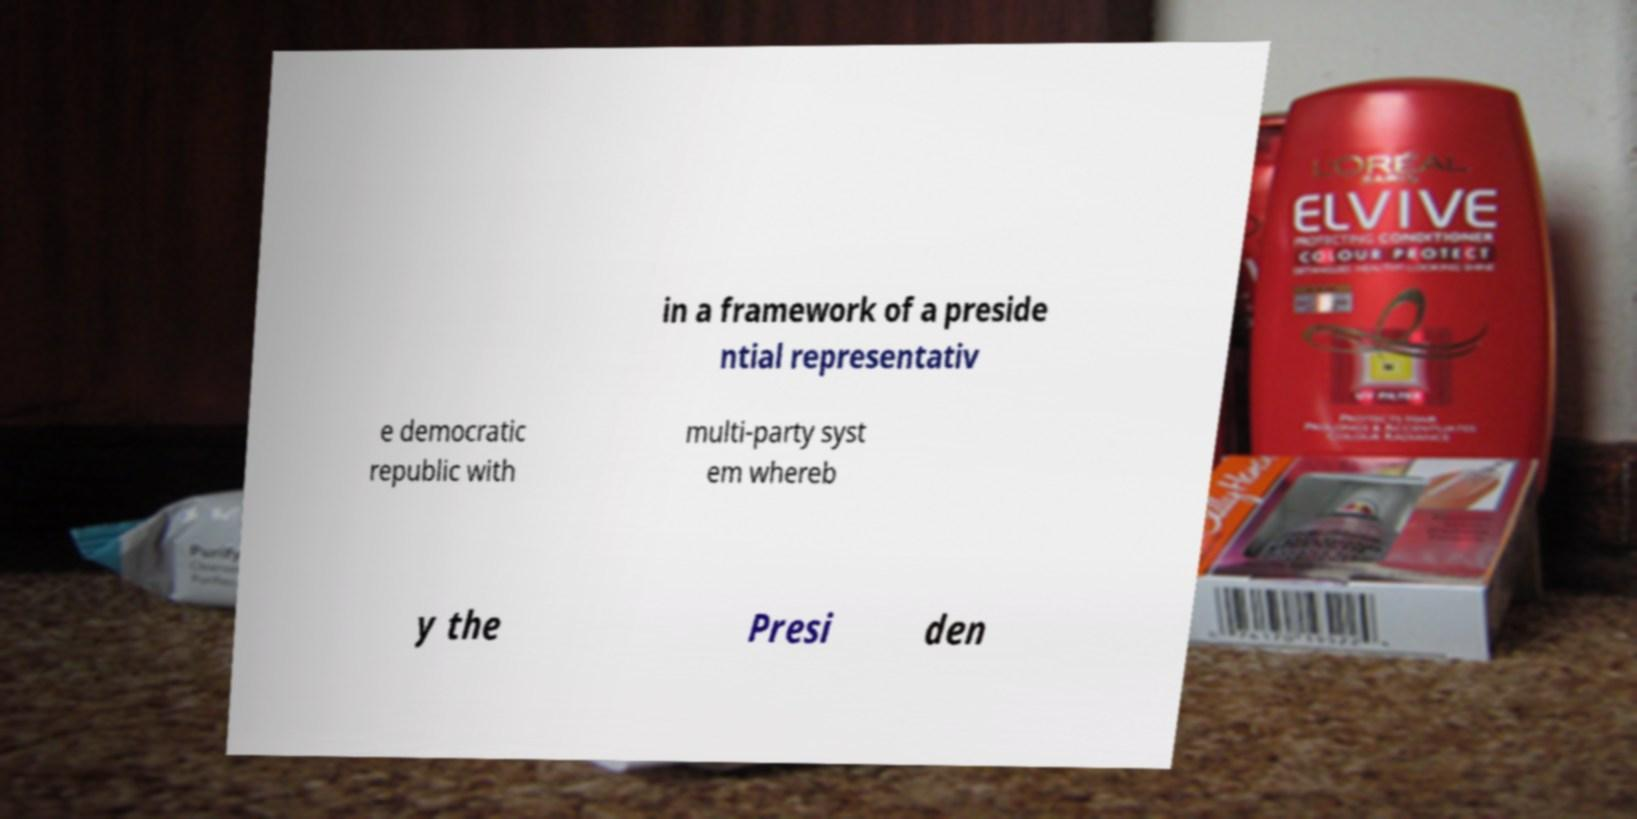I need the written content from this picture converted into text. Can you do that? in a framework of a preside ntial representativ e democratic republic with multi-party syst em whereb y the Presi den 